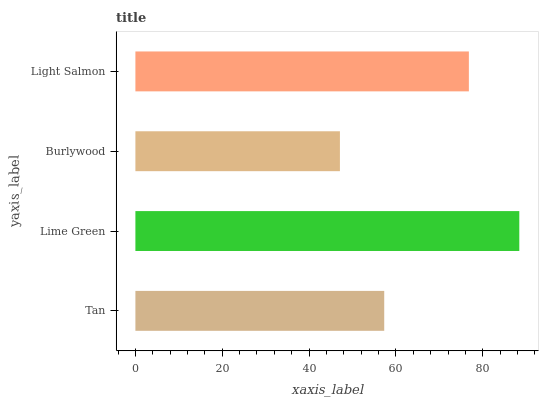Is Burlywood the minimum?
Answer yes or no. Yes. Is Lime Green the maximum?
Answer yes or no. Yes. Is Lime Green the minimum?
Answer yes or no. No. Is Burlywood the maximum?
Answer yes or no. No. Is Lime Green greater than Burlywood?
Answer yes or no. Yes. Is Burlywood less than Lime Green?
Answer yes or no. Yes. Is Burlywood greater than Lime Green?
Answer yes or no. No. Is Lime Green less than Burlywood?
Answer yes or no. No. Is Light Salmon the high median?
Answer yes or no. Yes. Is Tan the low median?
Answer yes or no. Yes. Is Burlywood the high median?
Answer yes or no. No. Is Light Salmon the low median?
Answer yes or no. No. 